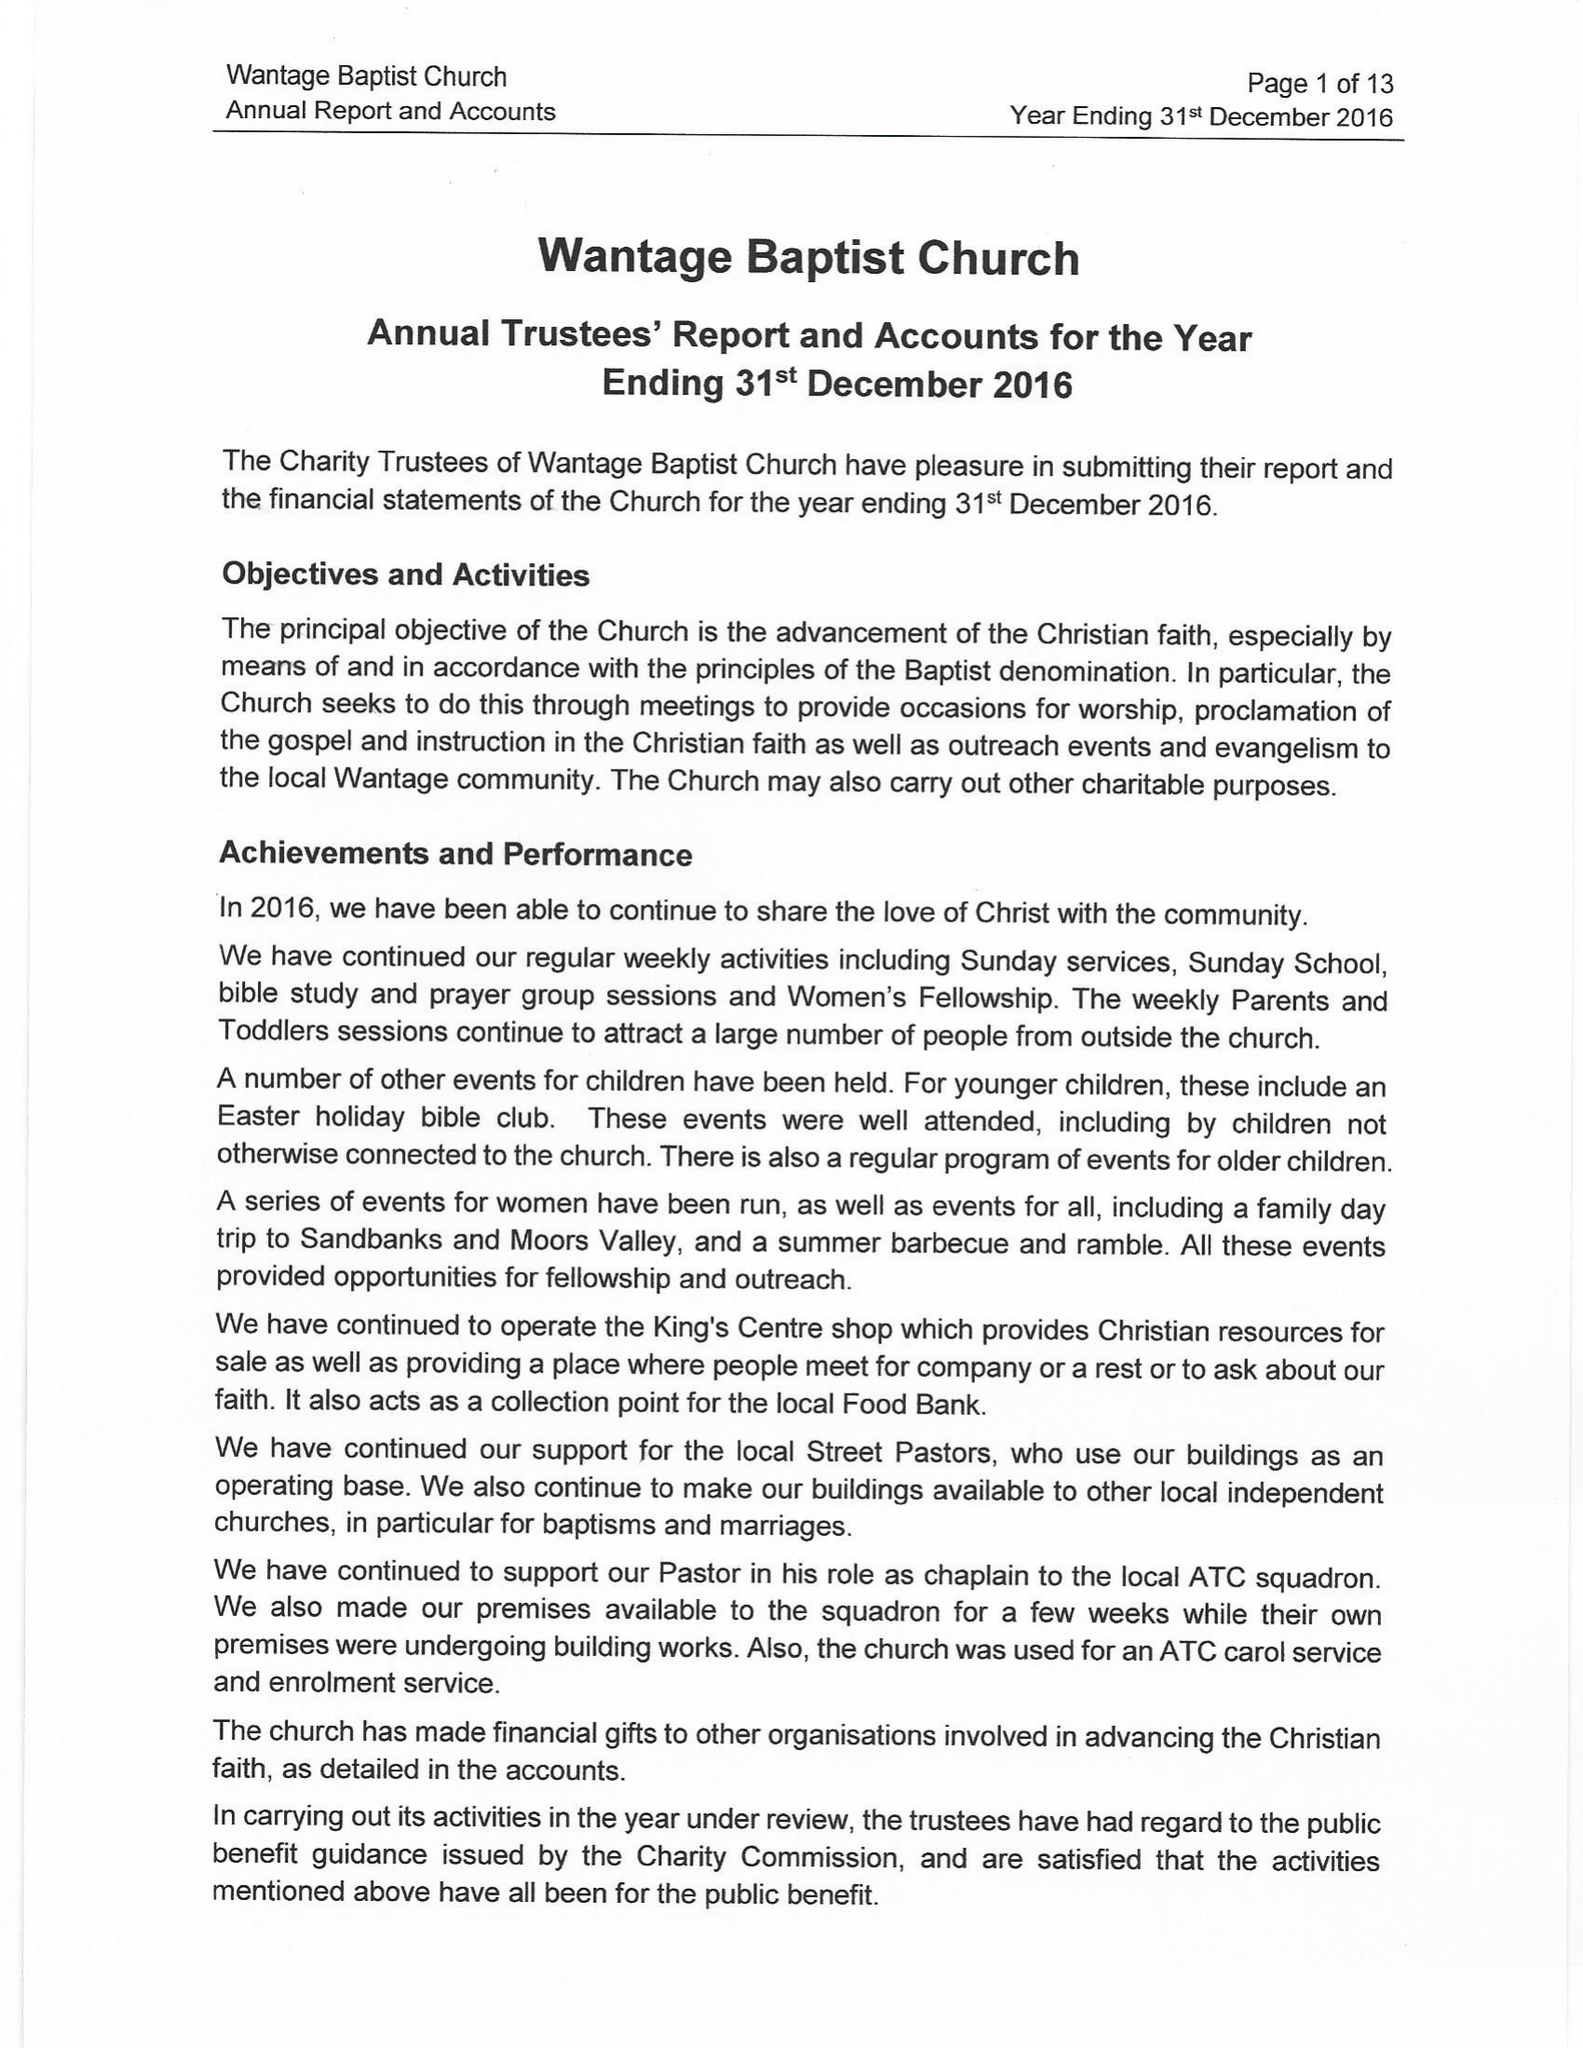What is the value for the income_annually_in_british_pounds?
Answer the question using a single word or phrase. 85893.00 